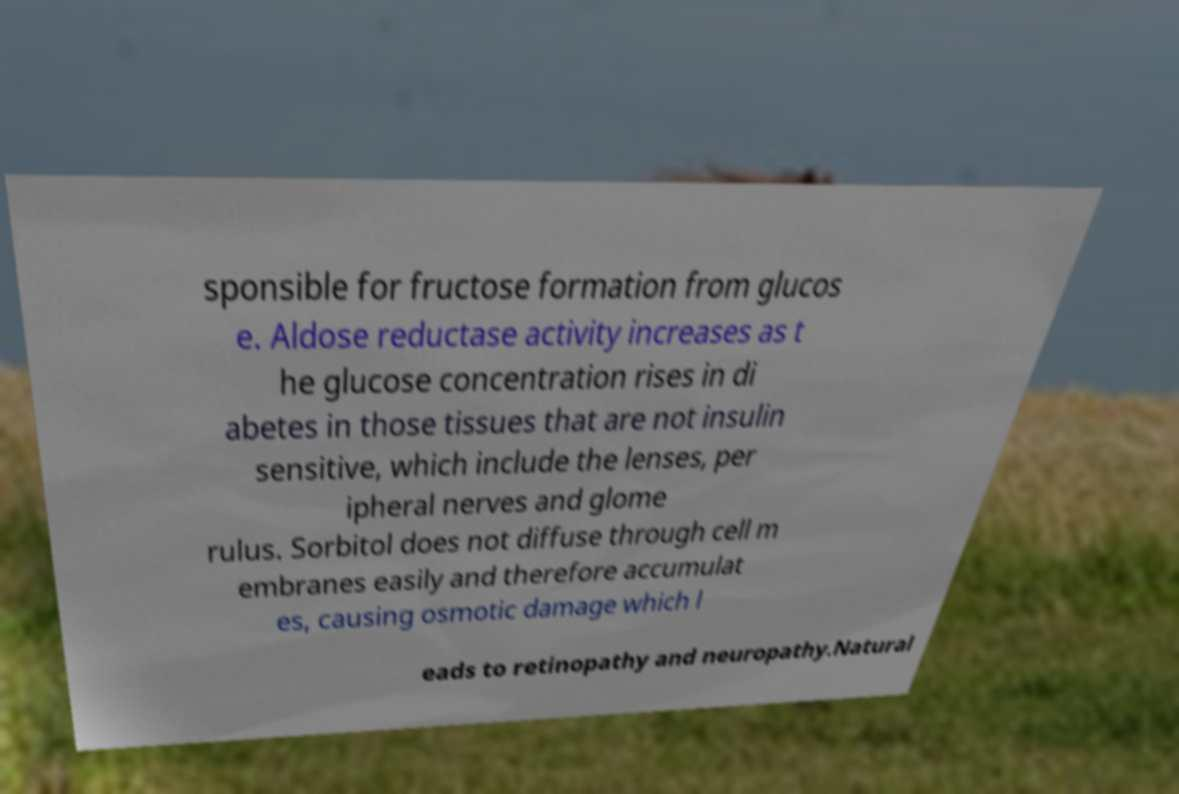I need the written content from this picture converted into text. Can you do that? sponsible for fructose formation from glucos e. Aldose reductase activity increases as t he glucose concentration rises in di abetes in those tissues that are not insulin sensitive, which include the lenses, per ipheral nerves and glome rulus. Sorbitol does not diffuse through cell m embranes easily and therefore accumulat es, causing osmotic damage which l eads to retinopathy and neuropathy.Natural 